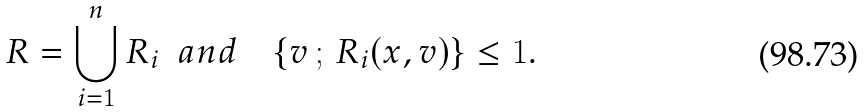<formula> <loc_0><loc_0><loc_500><loc_500>R = \bigcup _ { i = 1 } ^ { n } R _ { i } \ \ a n d \quad \{ v \, ; \, R _ { i } ( x , v ) \} \leq 1 .</formula> 